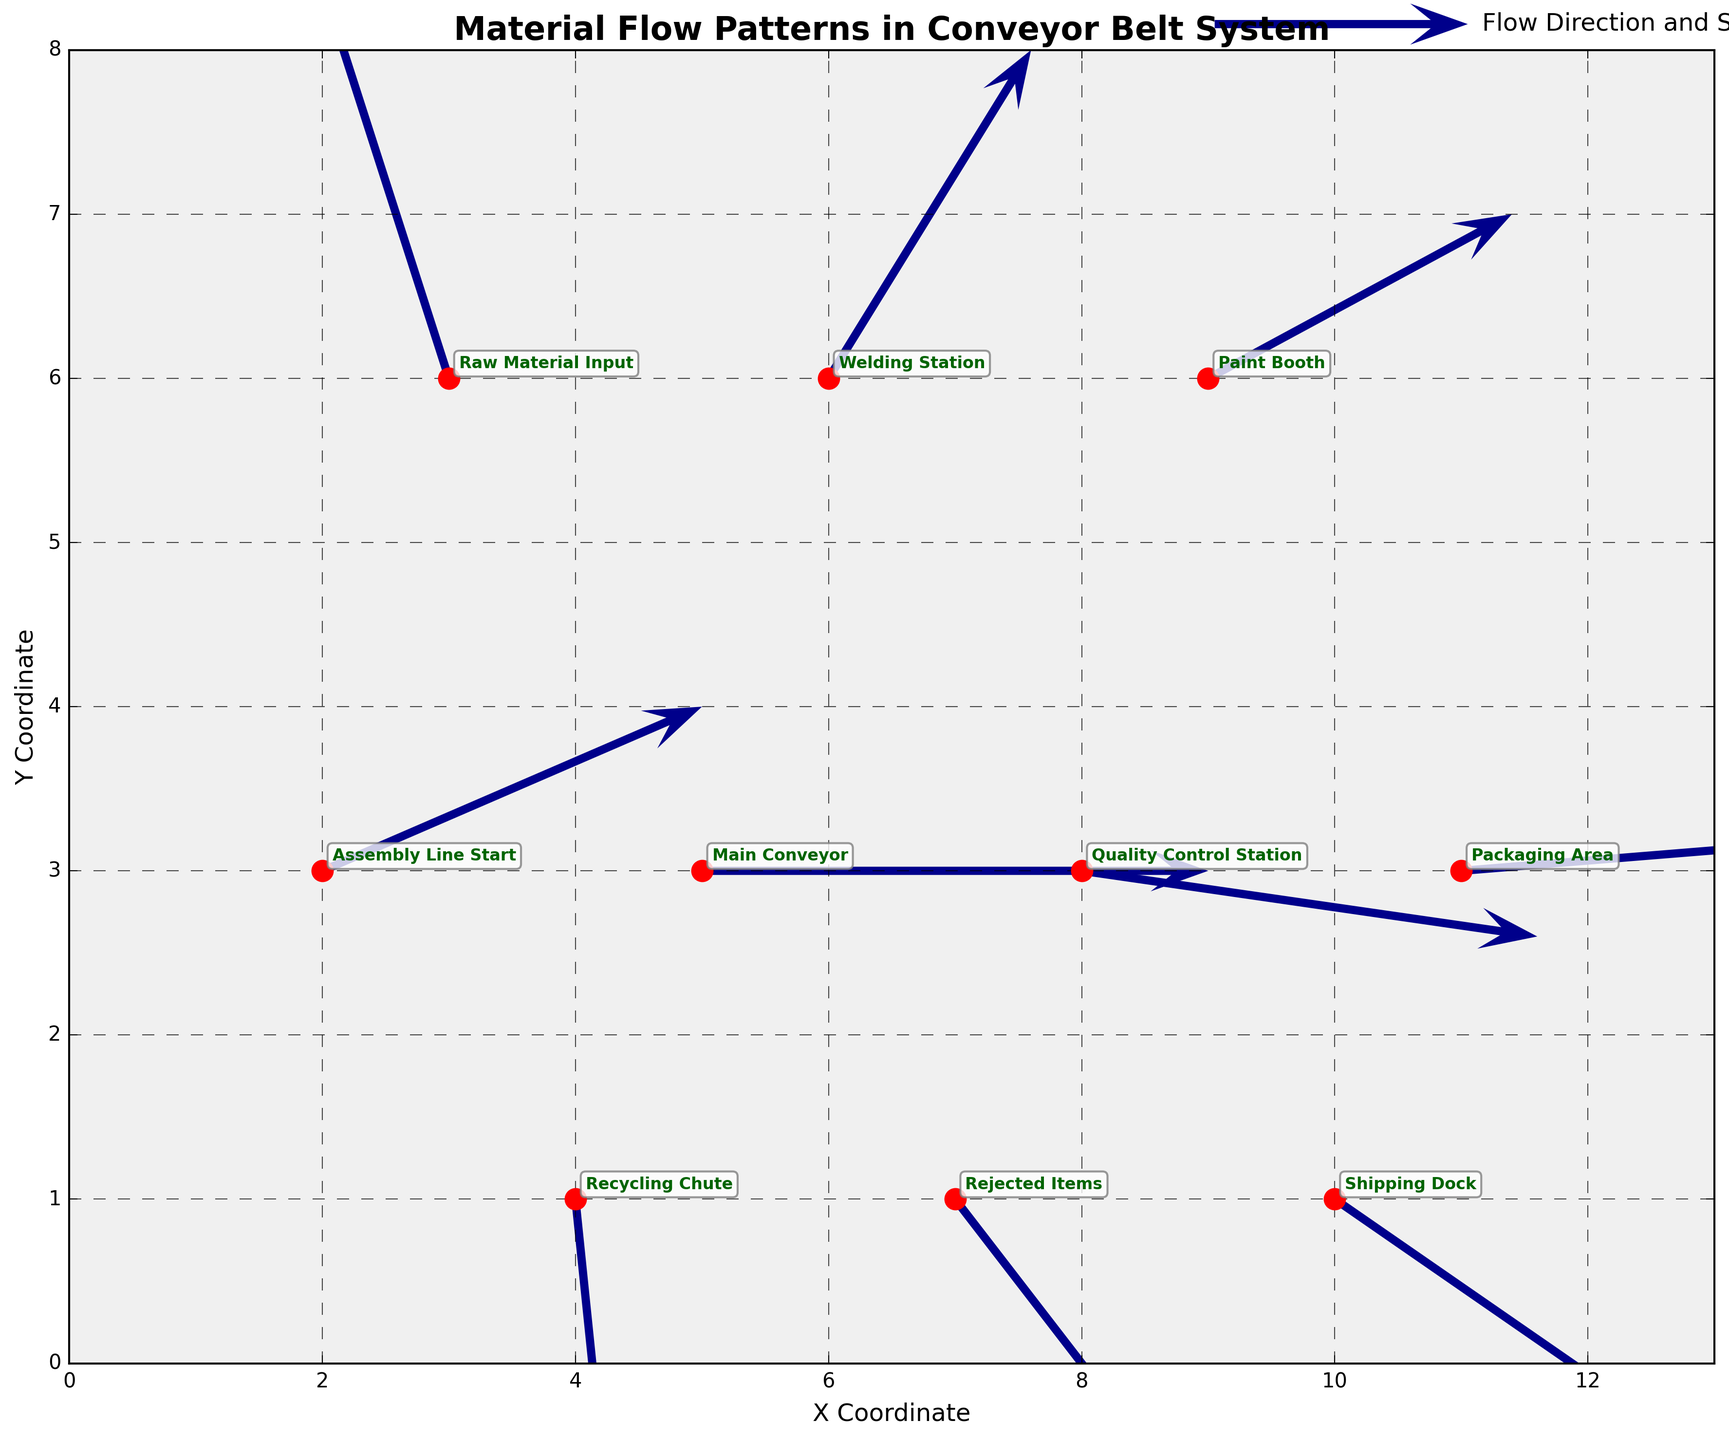What's the title of the figure? The title of the figure is usually positioned at the top center of the plot. In this case, the title is clearly marked as “Material Flow Patterns in Conveyor Belt System.”
Answer: Material Flow Patterns in Conveyor Belt System What are the labels of the X and Y axes? The labels of the axes provide context for the coordinates in the plot. The figure’s X-axis label is “X Coordinate,” and the Y-axis label is “Y Coordinate.”
Answer: X Coordinate, Y Coordinate Which point shows the origin of the recycling chute? The recycling chute is marked in the dataset with the coordinates (4,1) and the label “Recycling Chute.” This point is visually depicted near the bottom left of the plot.
Answer: Recycling Chute How many points are displayed in the plot? The dataset contains ten entries, each corresponding to a distinct point. This can be verified both by counting the data points in the dataset and confirming visually in the plot.
Answer: 10 Which station has the highest speed component on the X-axis? The speed component on the X-axis is given by the 'u' value. Looking at the dataset, the point with the highest 'u' value is the “Assembly Line Start” with 'u' = 1.5. Let’s check the plot to confirm.
Answer: Assembly Line Start What is the average X-coordinate of the points along the main conveyor belt (excluding the recycling chute and rejected items)? First, identify the X-coordinates of points along the main conveyor belt: (2,3), (5,3), (8,3), and (11,3). Sum these X-coordinates: 2+5+8+11 = 26. The average X-coordinate is 26 / 4 = 6.5.
Answer: 6.5 Which station has the slowest speed in the Y direction? The speed component on the Y-axis is given by the 'v' value. The “Recycling Chute” has a 'v' value of -1.5, indicating the slowest speed in the Y direction.
Answer: Recycling Chute How does the direction of material flow differ at the Quality Control Station compared to the Main Conveyor? Compare the vectors at both points: Main Conveyor has components (2,0) while Quality Control Station has components (1.8, -0.2). This indicates the flow is less straightforward or divergent at the Quality Control Station.
Answer: Divergent at Quality Control What is the sum of the X-axis components of speed for all the points? Sum the 'u' values from the dataset: 1.5+2+1.8+1.6-0.5+0.8+1.2+0.2+1+1.5 = 11.1. This sum represents the total X-axis movement direction and speed.
Answer: 11.1 What is the ratio of the Y-axis speed component of the Welding Station to the Paint Booth? The 'v' value of Welding Station is 1, and 'v' value of Paint Booth is 0.5. The ratio 1:0.5 simplifies to 2:1, indicating that welding has twice the Y-axis speed as painting.
Answer: 2:1 